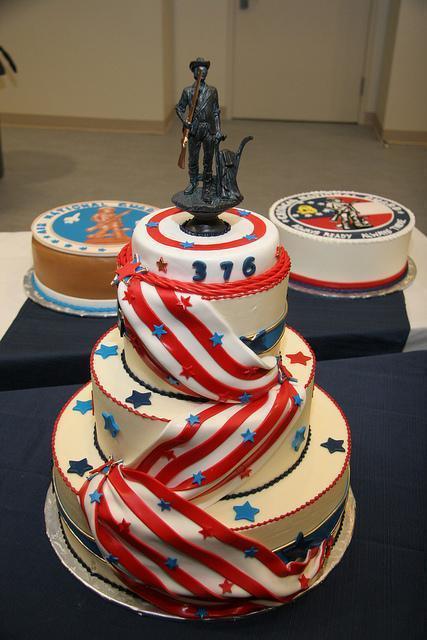How many cakes can you see?
Give a very brief answer. 3. How many dining tables can be seen?
Give a very brief answer. 1. 